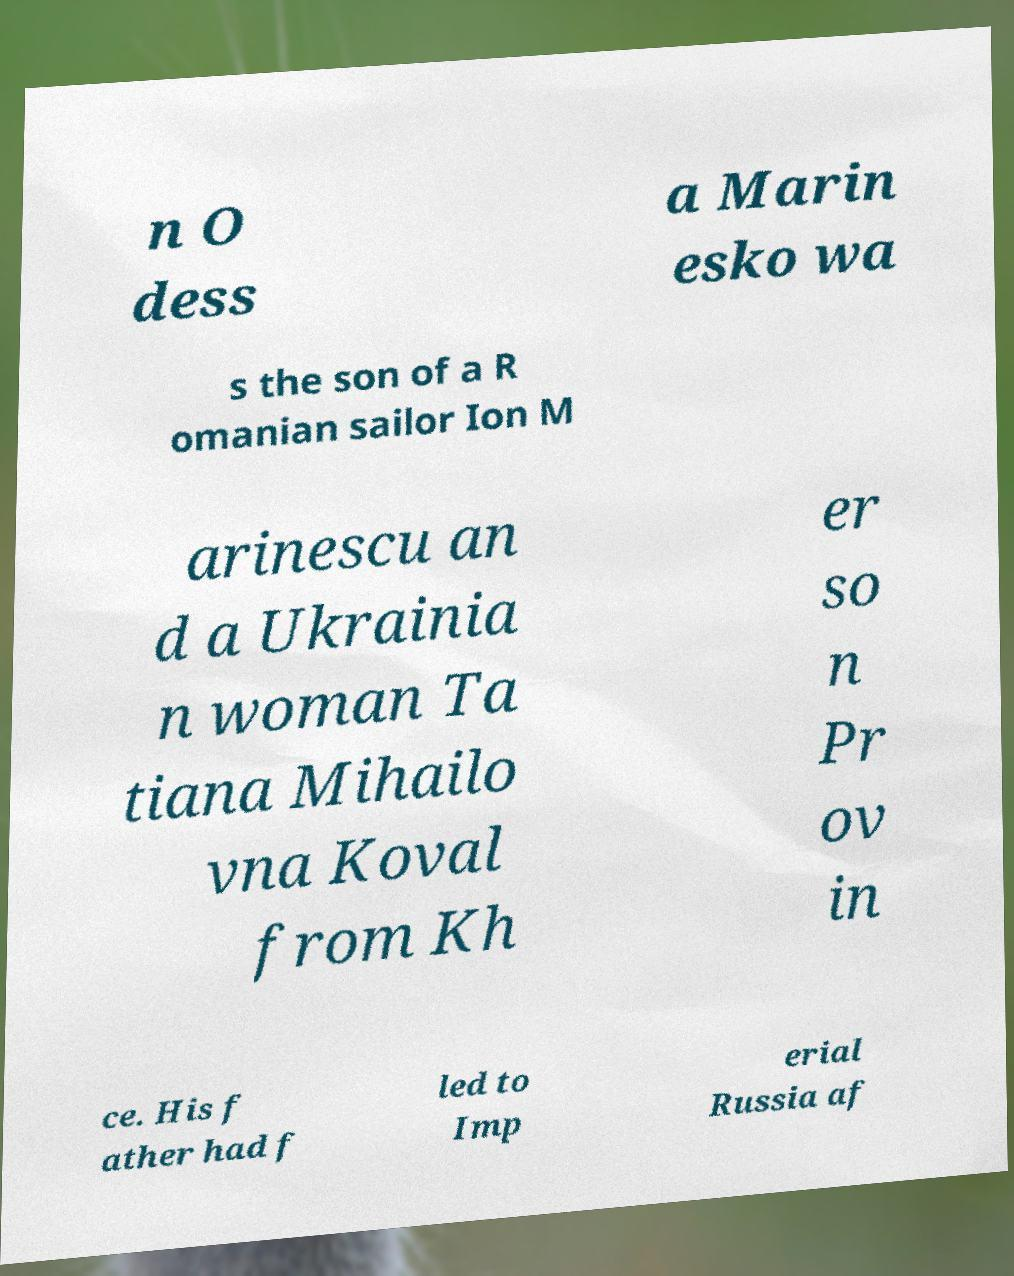Please read and relay the text visible in this image. What does it say? n O dess a Marin esko wa s the son of a R omanian sailor Ion M arinescu an d a Ukrainia n woman Ta tiana Mihailo vna Koval from Kh er so n Pr ov in ce. His f ather had f led to Imp erial Russia af 